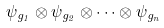<formula> <loc_0><loc_0><loc_500><loc_500>\psi _ { g _ { 1 } } \otimes \psi _ { g _ { 2 } } \otimes \cdots \otimes \psi _ { g _ { n } }</formula> 